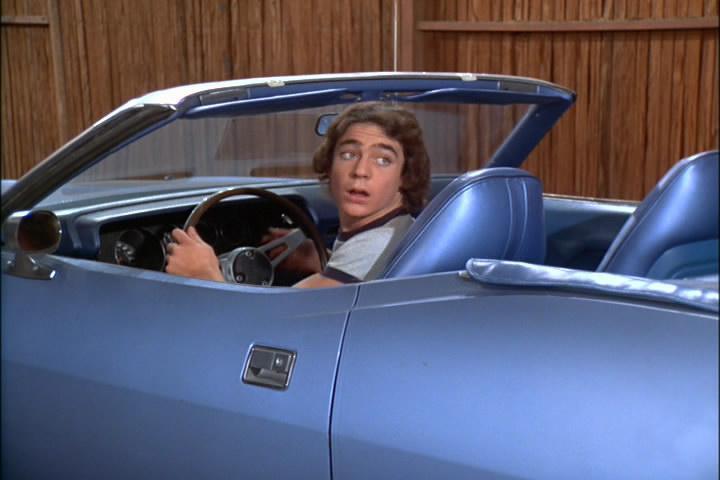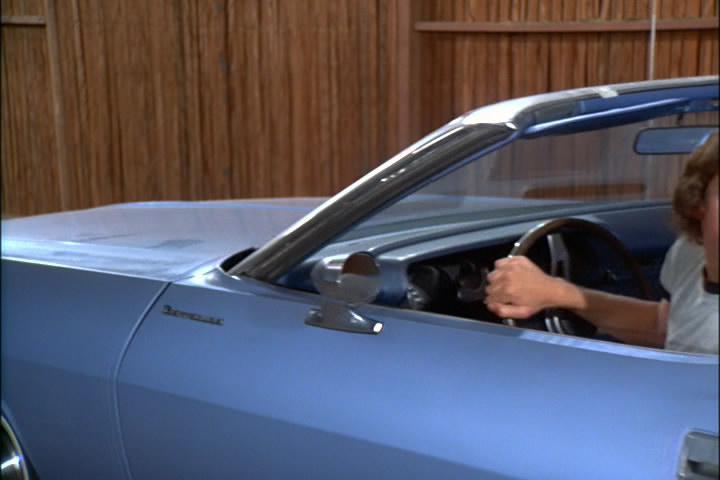The first image is the image on the left, the second image is the image on the right. For the images displayed, is the sentence "Each image shows a person behind the wheel of a convertible." factually correct? Answer yes or no. Yes. The first image is the image on the left, the second image is the image on the right. Assess this claim about the two images: "All of the cars in the images are sky blue.". Correct or not? Answer yes or no. Yes. 